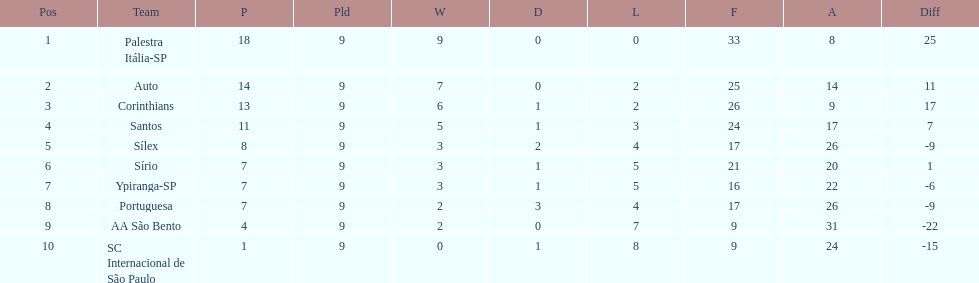In 1926 brazilian football,what was the total number of points scored? 90. 